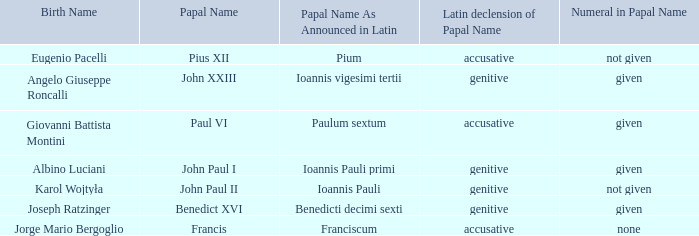In regard to the pope born eugenio pacelli, what is the variation of his papal moniker? Accusative. 